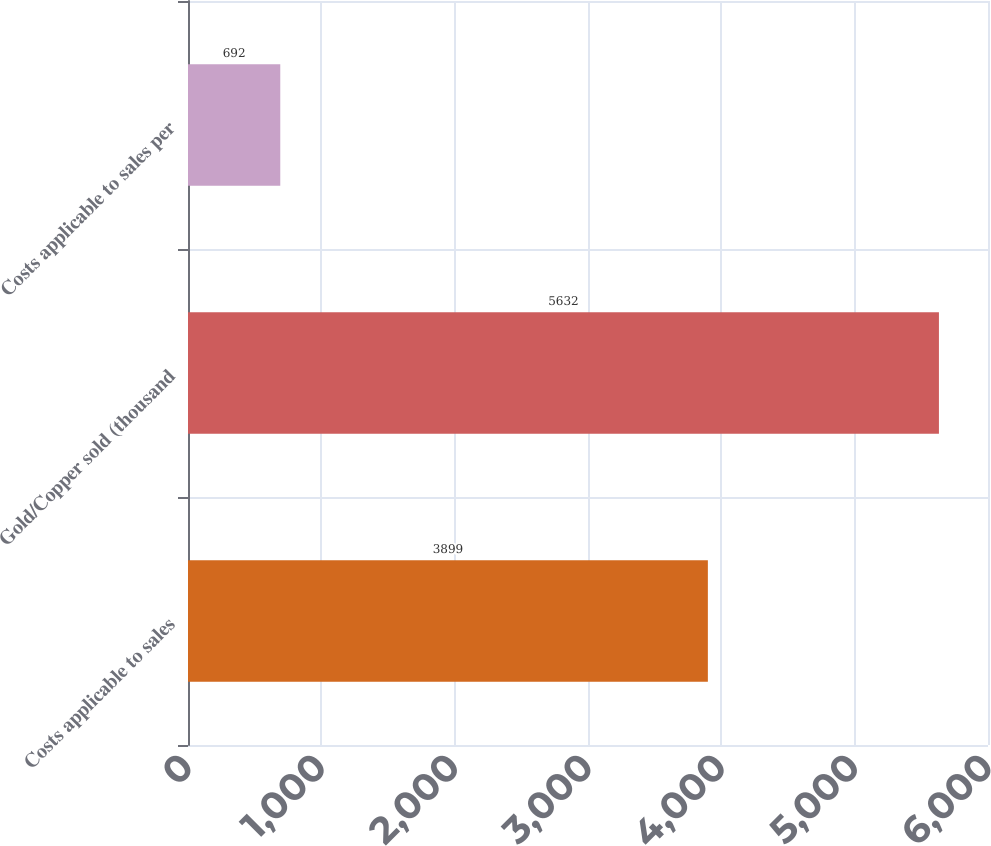<chart> <loc_0><loc_0><loc_500><loc_500><bar_chart><fcel>Costs applicable to sales<fcel>Gold/Copper sold (thousand<fcel>Costs applicable to sales per<nl><fcel>3899<fcel>5632<fcel>692<nl></chart> 